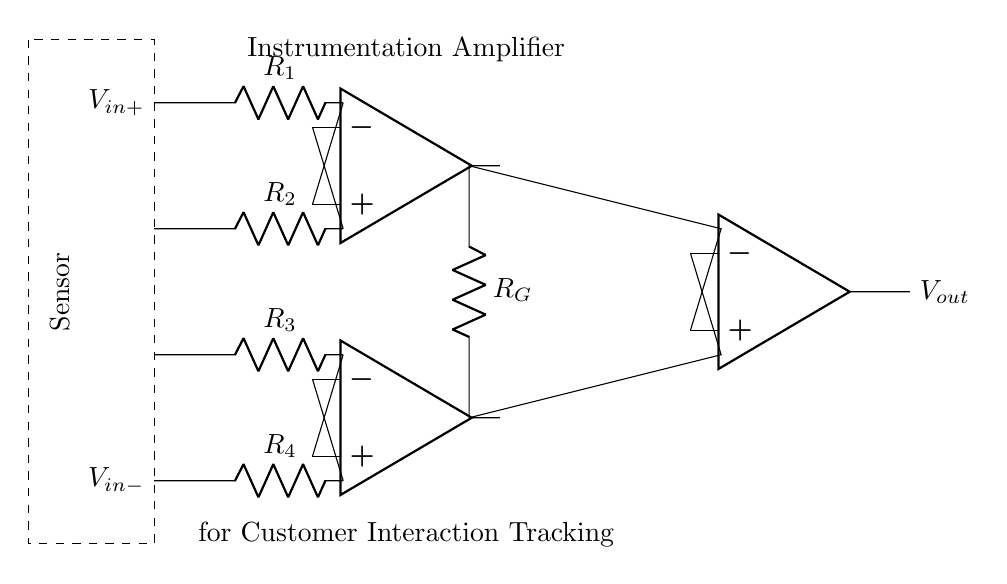What type of amplifier is shown in the diagram? The circuit diagram depicts an instrumentation amplifier, which is characterized by its use of three operational amplifiers to amplify small differential signals with high precision.
Answer: instrumentation amplifier What is the purpose of the resistor labeled R G? Resistor R G, also commonly known as the gain resistor, determines the overall gain of the instrumentation amplifier, affecting how much the input signals are amplified.
Answer: gain resistor How many operational amplifiers are used in this circuit? There are three operational amplifiers used in this instrumentation amplifier circuit. Each op-amp serves a specific role in the amplification process.
Answer: three What are the inputs to this amplifier? The inputs to the amplifier are labeled as V in+ and V in-, representing the positive and negative input voltage terminals, respectively, which receive the differential signals from the sensor.
Answer: V in+ and V in- What is the output voltage of the circuit labeled as? The output voltage of the circuit is labeled as V out, which represents the amplified version of the difference between the input signals received by the amplifier.
Answer: V out Why is the instrumentation amplifier preferred for sensor readings? The instrumentation amplifier is preferred for sensor readings due to its high input impedance, which minimizes the loading effect on the sensor, and its ability to reject common-mode noise, ensuring accurate readings.
Answer: high input impedance and common-mode rejection What kind of components are connected to the input terminals? The components connected to the input terminals are resistors, specifically R 1, R 2, R 3, and R 4, which are used to set the gain and provide the necessary feedback in the amplifier circuit.
Answer: resistors 